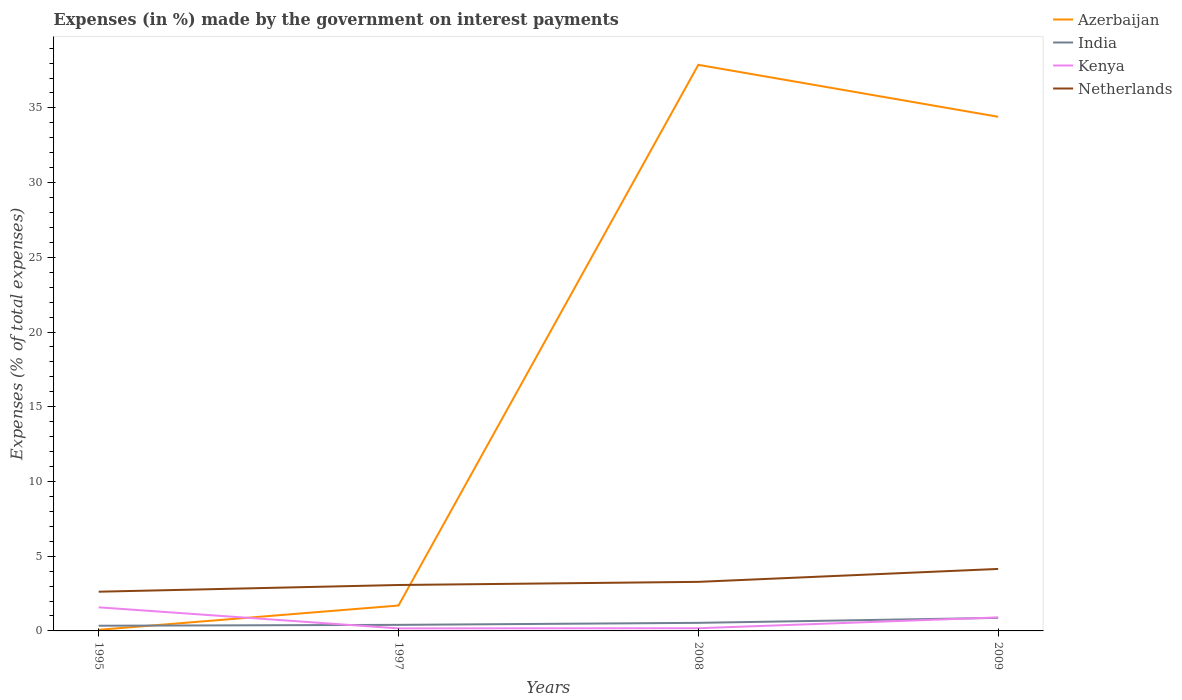Does the line corresponding to Kenya intersect with the line corresponding to India?
Your answer should be very brief. Yes. Is the number of lines equal to the number of legend labels?
Make the answer very short. Yes. Across all years, what is the maximum percentage of expenses made by the government on interest payments in Azerbaijan?
Give a very brief answer. 0.07. What is the total percentage of expenses made by the government on interest payments in Azerbaijan in the graph?
Give a very brief answer. -32.71. What is the difference between the highest and the second highest percentage of expenses made by the government on interest payments in Azerbaijan?
Offer a very short reply. 37.81. What is the difference between the highest and the lowest percentage of expenses made by the government on interest payments in Azerbaijan?
Offer a very short reply. 2. Is the percentage of expenses made by the government on interest payments in Azerbaijan strictly greater than the percentage of expenses made by the government on interest payments in India over the years?
Provide a short and direct response. No. How many years are there in the graph?
Keep it short and to the point. 4. Are the values on the major ticks of Y-axis written in scientific E-notation?
Provide a succinct answer. No. Does the graph contain any zero values?
Your answer should be very brief. No. Does the graph contain grids?
Offer a terse response. No. Where does the legend appear in the graph?
Provide a short and direct response. Top right. How are the legend labels stacked?
Ensure brevity in your answer.  Vertical. What is the title of the graph?
Make the answer very short. Expenses (in %) made by the government on interest payments. Does "Namibia" appear as one of the legend labels in the graph?
Provide a succinct answer. No. What is the label or title of the X-axis?
Keep it short and to the point. Years. What is the label or title of the Y-axis?
Provide a succinct answer. Expenses (% of total expenses). What is the Expenses (% of total expenses) in Azerbaijan in 1995?
Make the answer very short. 0.07. What is the Expenses (% of total expenses) in India in 1995?
Offer a terse response. 0.35. What is the Expenses (% of total expenses) in Kenya in 1995?
Your answer should be compact. 1.58. What is the Expenses (% of total expenses) in Netherlands in 1995?
Offer a very short reply. 2.62. What is the Expenses (% of total expenses) in Azerbaijan in 1997?
Offer a very short reply. 1.7. What is the Expenses (% of total expenses) in India in 1997?
Provide a succinct answer. 0.41. What is the Expenses (% of total expenses) of Kenya in 1997?
Your response must be concise. 0.17. What is the Expenses (% of total expenses) in Netherlands in 1997?
Give a very brief answer. 3.07. What is the Expenses (% of total expenses) in Azerbaijan in 2008?
Your answer should be very brief. 37.88. What is the Expenses (% of total expenses) in India in 2008?
Keep it short and to the point. 0.54. What is the Expenses (% of total expenses) of Kenya in 2008?
Provide a short and direct response. 0.18. What is the Expenses (% of total expenses) in Netherlands in 2008?
Ensure brevity in your answer.  3.28. What is the Expenses (% of total expenses) in Azerbaijan in 2009?
Ensure brevity in your answer.  34.41. What is the Expenses (% of total expenses) of India in 2009?
Your answer should be compact. 0.87. What is the Expenses (% of total expenses) of Kenya in 2009?
Your response must be concise. 0.9. What is the Expenses (% of total expenses) in Netherlands in 2009?
Provide a short and direct response. 4.15. Across all years, what is the maximum Expenses (% of total expenses) in Azerbaijan?
Give a very brief answer. 37.88. Across all years, what is the maximum Expenses (% of total expenses) in India?
Give a very brief answer. 0.87. Across all years, what is the maximum Expenses (% of total expenses) of Kenya?
Keep it short and to the point. 1.58. Across all years, what is the maximum Expenses (% of total expenses) in Netherlands?
Provide a short and direct response. 4.15. Across all years, what is the minimum Expenses (% of total expenses) of Azerbaijan?
Make the answer very short. 0.07. Across all years, what is the minimum Expenses (% of total expenses) of India?
Keep it short and to the point. 0.35. Across all years, what is the minimum Expenses (% of total expenses) in Kenya?
Make the answer very short. 0.17. Across all years, what is the minimum Expenses (% of total expenses) in Netherlands?
Offer a terse response. 2.62. What is the total Expenses (% of total expenses) in Azerbaijan in the graph?
Make the answer very short. 74.06. What is the total Expenses (% of total expenses) of India in the graph?
Give a very brief answer. 2.17. What is the total Expenses (% of total expenses) of Kenya in the graph?
Your answer should be very brief. 2.83. What is the total Expenses (% of total expenses) of Netherlands in the graph?
Provide a succinct answer. 13.13. What is the difference between the Expenses (% of total expenses) of Azerbaijan in 1995 and that in 1997?
Provide a succinct answer. -1.63. What is the difference between the Expenses (% of total expenses) of India in 1995 and that in 1997?
Your answer should be very brief. -0.06. What is the difference between the Expenses (% of total expenses) in Kenya in 1995 and that in 1997?
Offer a terse response. 1.41. What is the difference between the Expenses (% of total expenses) in Netherlands in 1995 and that in 1997?
Give a very brief answer. -0.45. What is the difference between the Expenses (% of total expenses) of Azerbaijan in 1995 and that in 2008?
Give a very brief answer. -37.81. What is the difference between the Expenses (% of total expenses) of India in 1995 and that in 2008?
Keep it short and to the point. -0.19. What is the difference between the Expenses (% of total expenses) in Kenya in 1995 and that in 2008?
Your response must be concise. 1.4. What is the difference between the Expenses (% of total expenses) of Netherlands in 1995 and that in 2008?
Keep it short and to the point. -0.66. What is the difference between the Expenses (% of total expenses) of Azerbaijan in 1995 and that in 2009?
Make the answer very short. -34.33. What is the difference between the Expenses (% of total expenses) in India in 1995 and that in 2009?
Make the answer very short. -0.53. What is the difference between the Expenses (% of total expenses) in Kenya in 1995 and that in 2009?
Make the answer very short. 0.67. What is the difference between the Expenses (% of total expenses) of Netherlands in 1995 and that in 2009?
Your answer should be compact. -1.52. What is the difference between the Expenses (% of total expenses) of Azerbaijan in 1997 and that in 2008?
Offer a terse response. -36.18. What is the difference between the Expenses (% of total expenses) in India in 1997 and that in 2008?
Offer a terse response. -0.13. What is the difference between the Expenses (% of total expenses) of Kenya in 1997 and that in 2008?
Make the answer very short. -0.01. What is the difference between the Expenses (% of total expenses) of Netherlands in 1997 and that in 2008?
Make the answer very short. -0.21. What is the difference between the Expenses (% of total expenses) in Azerbaijan in 1997 and that in 2009?
Give a very brief answer. -32.71. What is the difference between the Expenses (% of total expenses) in India in 1997 and that in 2009?
Provide a succinct answer. -0.47. What is the difference between the Expenses (% of total expenses) of Kenya in 1997 and that in 2009?
Make the answer very short. -0.73. What is the difference between the Expenses (% of total expenses) in Netherlands in 1997 and that in 2009?
Your response must be concise. -1.08. What is the difference between the Expenses (% of total expenses) in Azerbaijan in 2008 and that in 2009?
Offer a terse response. 3.48. What is the difference between the Expenses (% of total expenses) of India in 2008 and that in 2009?
Offer a very short reply. -0.33. What is the difference between the Expenses (% of total expenses) of Kenya in 2008 and that in 2009?
Ensure brevity in your answer.  -0.72. What is the difference between the Expenses (% of total expenses) in Netherlands in 2008 and that in 2009?
Your answer should be very brief. -0.86. What is the difference between the Expenses (% of total expenses) in Azerbaijan in 1995 and the Expenses (% of total expenses) in India in 1997?
Offer a terse response. -0.33. What is the difference between the Expenses (% of total expenses) of Azerbaijan in 1995 and the Expenses (% of total expenses) of Kenya in 1997?
Offer a terse response. -0.1. What is the difference between the Expenses (% of total expenses) in Azerbaijan in 1995 and the Expenses (% of total expenses) in Netherlands in 1997?
Keep it short and to the point. -3. What is the difference between the Expenses (% of total expenses) of India in 1995 and the Expenses (% of total expenses) of Kenya in 1997?
Keep it short and to the point. 0.18. What is the difference between the Expenses (% of total expenses) in India in 1995 and the Expenses (% of total expenses) in Netherlands in 1997?
Give a very brief answer. -2.72. What is the difference between the Expenses (% of total expenses) of Kenya in 1995 and the Expenses (% of total expenses) of Netherlands in 1997?
Offer a terse response. -1.49. What is the difference between the Expenses (% of total expenses) in Azerbaijan in 1995 and the Expenses (% of total expenses) in India in 2008?
Offer a very short reply. -0.47. What is the difference between the Expenses (% of total expenses) of Azerbaijan in 1995 and the Expenses (% of total expenses) of Kenya in 2008?
Your response must be concise. -0.11. What is the difference between the Expenses (% of total expenses) of Azerbaijan in 1995 and the Expenses (% of total expenses) of Netherlands in 2008?
Keep it short and to the point. -3.21. What is the difference between the Expenses (% of total expenses) of India in 1995 and the Expenses (% of total expenses) of Kenya in 2008?
Your response must be concise. 0.17. What is the difference between the Expenses (% of total expenses) in India in 1995 and the Expenses (% of total expenses) in Netherlands in 2008?
Keep it short and to the point. -2.94. What is the difference between the Expenses (% of total expenses) in Kenya in 1995 and the Expenses (% of total expenses) in Netherlands in 2008?
Offer a very short reply. -1.7. What is the difference between the Expenses (% of total expenses) in Azerbaijan in 1995 and the Expenses (% of total expenses) in India in 2009?
Your answer should be very brief. -0.8. What is the difference between the Expenses (% of total expenses) in Azerbaijan in 1995 and the Expenses (% of total expenses) in Kenya in 2009?
Your answer should be very brief. -0.83. What is the difference between the Expenses (% of total expenses) in Azerbaijan in 1995 and the Expenses (% of total expenses) in Netherlands in 2009?
Offer a very short reply. -4.07. What is the difference between the Expenses (% of total expenses) of India in 1995 and the Expenses (% of total expenses) of Kenya in 2009?
Offer a very short reply. -0.56. What is the difference between the Expenses (% of total expenses) in India in 1995 and the Expenses (% of total expenses) in Netherlands in 2009?
Your answer should be compact. -3.8. What is the difference between the Expenses (% of total expenses) in Kenya in 1995 and the Expenses (% of total expenses) in Netherlands in 2009?
Make the answer very short. -2.57. What is the difference between the Expenses (% of total expenses) in Azerbaijan in 1997 and the Expenses (% of total expenses) in India in 2008?
Ensure brevity in your answer.  1.16. What is the difference between the Expenses (% of total expenses) of Azerbaijan in 1997 and the Expenses (% of total expenses) of Kenya in 2008?
Keep it short and to the point. 1.52. What is the difference between the Expenses (% of total expenses) in Azerbaijan in 1997 and the Expenses (% of total expenses) in Netherlands in 2008?
Keep it short and to the point. -1.58. What is the difference between the Expenses (% of total expenses) of India in 1997 and the Expenses (% of total expenses) of Kenya in 2008?
Give a very brief answer. 0.23. What is the difference between the Expenses (% of total expenses) in India in 1997 and the Expenses (% of total expenses) in Netherlands in 2008?
Provide a succinct answer. -2.88. What is the difference between the Expenses (% of total expenses) in Kenya in 1997 and the Expenses (% of total expenses) in Netherlands in 2008?
Your response must be concise. -3.11. What is the difference between the Expenses (% of total expenses) in Azerbaijan in 1997 and the Expenses (% of total expenses) in India in 2009?
Your response must be concise. 0.83. What is the difference between the Expenses (% of total expenses) in Azerbaijan in 1997 and the Expenses (% of total expenses) in Kenya in 2009?
Ensure brevity in your answer.  0.8. What is the difference between the Expenses (% of total expenses) of Azerbaijan in 1997 and the Expenses (% of total expenses) of Netherlands in 2009?
Give a very brief answer. -2.45. What is the difference between the Expenses (% of total expenses) of India in 1997 and the Expenses (% of total expenses) of Kenya in 2009?
Offer a very short reply. -0.5. What is the difference between the Expenses (% of total expenses) of India in 1997 and the Expenses (% of total expenses) of Netherlands in 2009?
Make the answer very short. -3.74. What is the difference between the Expenses (% of total expenses) in Kenya in 1997 and the Expenses (% of total expenses) in Netherlands in 2009?
Give a very brief answer. -3.98. What is the difference between the Expenses (% of total expenses) of Azerbaijan in 2008 and the Expenses (% of total expenses) of India in 2009?
Your answer should be compact. 37.01. What is the difference between the Expenses (% of total expenses) in Azerbaijan in 2008 and the Expenses (% of total expenses) in Kenya in 2009?
Provide a succinct answer. 36.98. What is the difference between the Expenses (% of total expenses) in Azerbaijan in 2008 and the Expenses (% of total expenses) in Netherlands in 2009?
Make the answer very short. 33.73. What is the difference between the Expenses (% of total expenses) of India in 2008 and the Expenses (% of total expenses) of Kenya in 2009?
Your answer should be very brief. -0.36. What is the difference between the Expenses (% of total expenses) in India in 2008 and the Expenses (% of total expenses) in Netherlands in 2009?
Make the answer very short. -3.61. What is the difference between the Expenses (% of total expenses) in Kenya in 2008 and the Expenses (% of total expenses) in Netherlands in 2009?
Offer a terse response. -3.97. What is the average Expenses (% of total expenses) of Azerbaijan per year?
Your answer should be compact. 18.52. What is the average Expenses (% of total expenses) in India per year?
Your answer should be compact. 0.54. What is the average Expenses (% of total expenses) of Kenya per year?
Your answer should be compact. 0.71. What is the average Expenses (% of total expenses) of Netherlands per year?
Provide a succinct answer. 3.28. In the year 1995, what is the difference between the Expenses (% of total expenses) of Azerbaijan and Expenses (% of total expenses) of India?
Your response must be concise. -0.27. In the year 1995, what is the difference between the Expenses (% of total expenses) in Azerbaijan and Expenses (% of total expenses) in Kenya?
Make the answer very short. -1.5. In the year 1995, what is the difference between the Expenses (% of total expenses) of Azerbaijan and Expenses (% of total expenses) of Netherlands?
Keep it short and to the point. -2.55. In the year 1995, what is the difference between the Expenses (% of total expenses) in India and Expenses (% of total expenses) in Kenya?
Your response must be concise. -1.23. In the year 1995, what is the difference between the Expenses (% of total expenses) of India and Expenses (% of total expenses) of Netherlands?
Give a very brief answer. -2.28. In the year 1995, what is the difference between the Expenses (% of total expenses) in Kenya and Expenses (% of total expenses) in Netherlands?
Provide a succinct answer. -1.05. In the year 1997, what is the difference between the Expenses (% of total expenses) in Azerbaijan and Expenses (% of total expenses) in India?
Provide a short and direct response. 1.29. In the year 1997, what is the difference between the Expenses (% of total expenses) in Azerbaijan and Expenses (% of total expenses) in Kenya?
Your answer should be very brief. 1.53. In the year 1997, what is the difference between the Expenses (% of total expenses) in Azerbaijan and Expenses (% of total expenses) in Netherlands?
Provide a succinct answer. -1.37. In the year 1997, what is the difference between the Expenses (% of total expenses) in India and Expenses (% of total expenses) in Kenya?
Offer a very short reply. 0.24. In the year 1997, what is the difference between the Expenses (% of total expenses) in India and Expenses (% of total expenses) in Netherlands?
Your answer should be very brief. -2.67. In the year 1997, what is the difference between the Expenses (% of total expenses) in Kenya and Expenses (% of total expenses) in Netherlands?
Keep it short and to the point. -2.9. In the year 2008, what is the difference between the Expenses (% of total expenses) in Azerbaijan and Expenses (% of total expenses) in India?
Provide a succinct answer. 37.34. In the year 2008, what is the difference between the Expenses (% of total expenses) in Azerbaijan and Expenses (% of total expenses) in Kenya?
Offer a very short reply. 37.7. In the year 2008, what is the difference between the Expenses (% of total expenses) in Azerbaijan and Expenses (% of total expenses) in Netherlands?
Keep it short and to the point. 34.6. In the year 2008, what is the difference between the Expenses (% of total expenses) of India and Expenses (% of total expenses) of Kenya?
Provide a succinct answer. 0.36. In the year 2008, what is the difference between the Expenses (% of total expenses) in India and Expenses (% of total expenses) in Netherlands?
Your answer should be compact. -2.74. In the year 2008, what is the difference between the Expenses (% of total expenses) in Kenya and Expenses (% of total expenses) in Netherlands?
Offer a terse response. -3.1. In the year 2009, what is the difference between the Expenses (% of total expenses) in Azerbaijan and Expenses (% of total expenses) in India?
Provide a short and direct response. 33.53. In the year 2009, what is the difference between the Expenses (% of total expenses) of Azerbaijan and Expenses (% of total expenses) of Kenya?
Your answer should be very brief. 33.5. In the year 2009, what is the difference between the Expenses (% of total expenses) in Azerbaijan and Expenses (% of total expenses) in Netherlands?
Offer a terse response. 30.26. In the year 2009, what is the difference between the Expenses (% of total expenses) of India and Expenses (% of total expenses) of Kenya?
Your answer should be compact. -0.03. In the year 2009, what is the difference between the Expenses (% of total expenses) of India and Expenses (% of total expenses) of Netherlands?
Your answer should be compact. -3.27. In the year 2009, what is the difference between the Expenses (% of total expenses) in Kenya and Expenses (% of total expenses) in Netherlands?
Give a very brief answer. -3.24. What is the ratio of the Expenses (% of total expenses) in Azerbaijan in 1995 to that in 1997?
Keep it short and to the point. 0.04. What is the ratio of the Expenses (% of total expenses) of India in 1995 to that in 1997?
Provide a succinct answer. 0.86. What is the ratio of the Expenses (% of total expenses) in Kenya in 1995 to that in 1997?
Provide a succinct answer. 9.33. What is the ratio of the Expenses (% of total expenses) in Netherlands in 1995 to that in 1997?
Provide a short and direct response. 0.85. What is the ratio of the Expenses (% of total expenses) of Azerbaijan in 1995 to that in 2008?
Your answer should be very brief. 0. What is the ratio of the Expenses (% of total expenses) in India in 1995 to that in 2008?
Your answer should be compact. 0.64. What is the ratio of the Expenses (% of total expenses) in Kenya in 1995 to that in 2008?
Offer a very short reply. 8.78. What is the ratio of the Expenses (% of total expenses) of Netherlands in 1995 to that in 2008?
Make the answer very short. 0.8. What is the ratio of the Expenses (% of total expenses) in Azerbaijan in 1995 to that in 2009?
Give a very brief answer. 0. What is the ratio of the Expenses (% of total expenses) in India in 1995 to that in 2009?
Make the answer very short. 0.4. What is the ratio of the Expenses (% of total expenses) of Kenya in 1995 to that in 2009?
Your answer should be compact. 1.75. What is the ratio of the Expenses (% of total expenses) of Netherlands in 1995 to that in 2009?
Your answer should be very brief. 0.63. What is the ratio of the Expenses (% of total expenses) in Azerbaijan in 1997 to that in 2008?
Your answer should be very brief. 0.04. What is the ratio of the Expenses (% of total expenses) in India in 1997 to that in 2008?
Provide a short and direct response. 0.75. What is the ratio of the Expenses (% of total expenses) of Kenya in 1997 to that in 2008?
Offer a terse response. 0.94. What is the ratio of the Expenses (% of total expenses) in Netherlands in 1997 to that in 2008?
Your answer should be very brief. 0.94. What is the ratio of the Expenses (% of total expenses) of Azerbaijan in 1997 to that in 2009?
Keep it short and to the point. 0.05. What is the ratio of the Expenses (% of total expenses) of India in 1997 to that in 2009?
Offer a terse response. 0.47. What is the ratio of the Expenses (% of total expenses) of Kenya in 1997 to that in 2009?
Offer a very short reply. 0.19. What is the ratio of the Expenses (% of total expenses) of Netherlands in 1997 to that in 2009?
Offer a very short reply. 0.74. What is the ratio of the Expenses (% of total expenses) in Azerbaijan in 2008 to that in 2009?
Give a very brief answer. 1.1. What is the ratio of the Expenses (% of total expenses) in India in 2008 to that in 2009?
Give a very brief answer. 0.62. What is the ratio of the Expenses (% of total expenses) in Kenya in 2008 to that in 2009?
Give a very brief answer. 0.2. What is the ratio of the Expenses (% of total expenses) of Netherlands in 2008 to that in 2009?
Offer a very short reply. 0.79. What is the difference between the highest and the second highest Expenses (% of total expenses) of Azerbaijan?
Provide a succinct answer. 3.48. What is the difference between the highest and the second highest Expenses (% of total expenses) of India?
Your answer should be very brief. 0.33. What is the difference between the highest and the second highest Expenses (% of total expenses) of Kenya?
Your answer should be compact. 0.67. What is the difference between the highest and the second highest Expenses (% of total expenses) of Netherlands?
Offer a very short reply. 0.86. What is the difference between the highest and the lowest Expenses (% of total expenses) of Azerbaijan?
Provide a succinct answer. 37.81. What is the difference between the highest and the lowest Expenses (% of total expenses) in India?
Your answer should be very brief. 0.53. What is the difference between the highest and the lowest Expenses (% of total expenses) of Kenya?
Your answer should be very brief. 1.41. What is the difference between the highest and the lowest Expenses (% of total expenses) of Netherlands?
Your response must be concise. 1.52. 